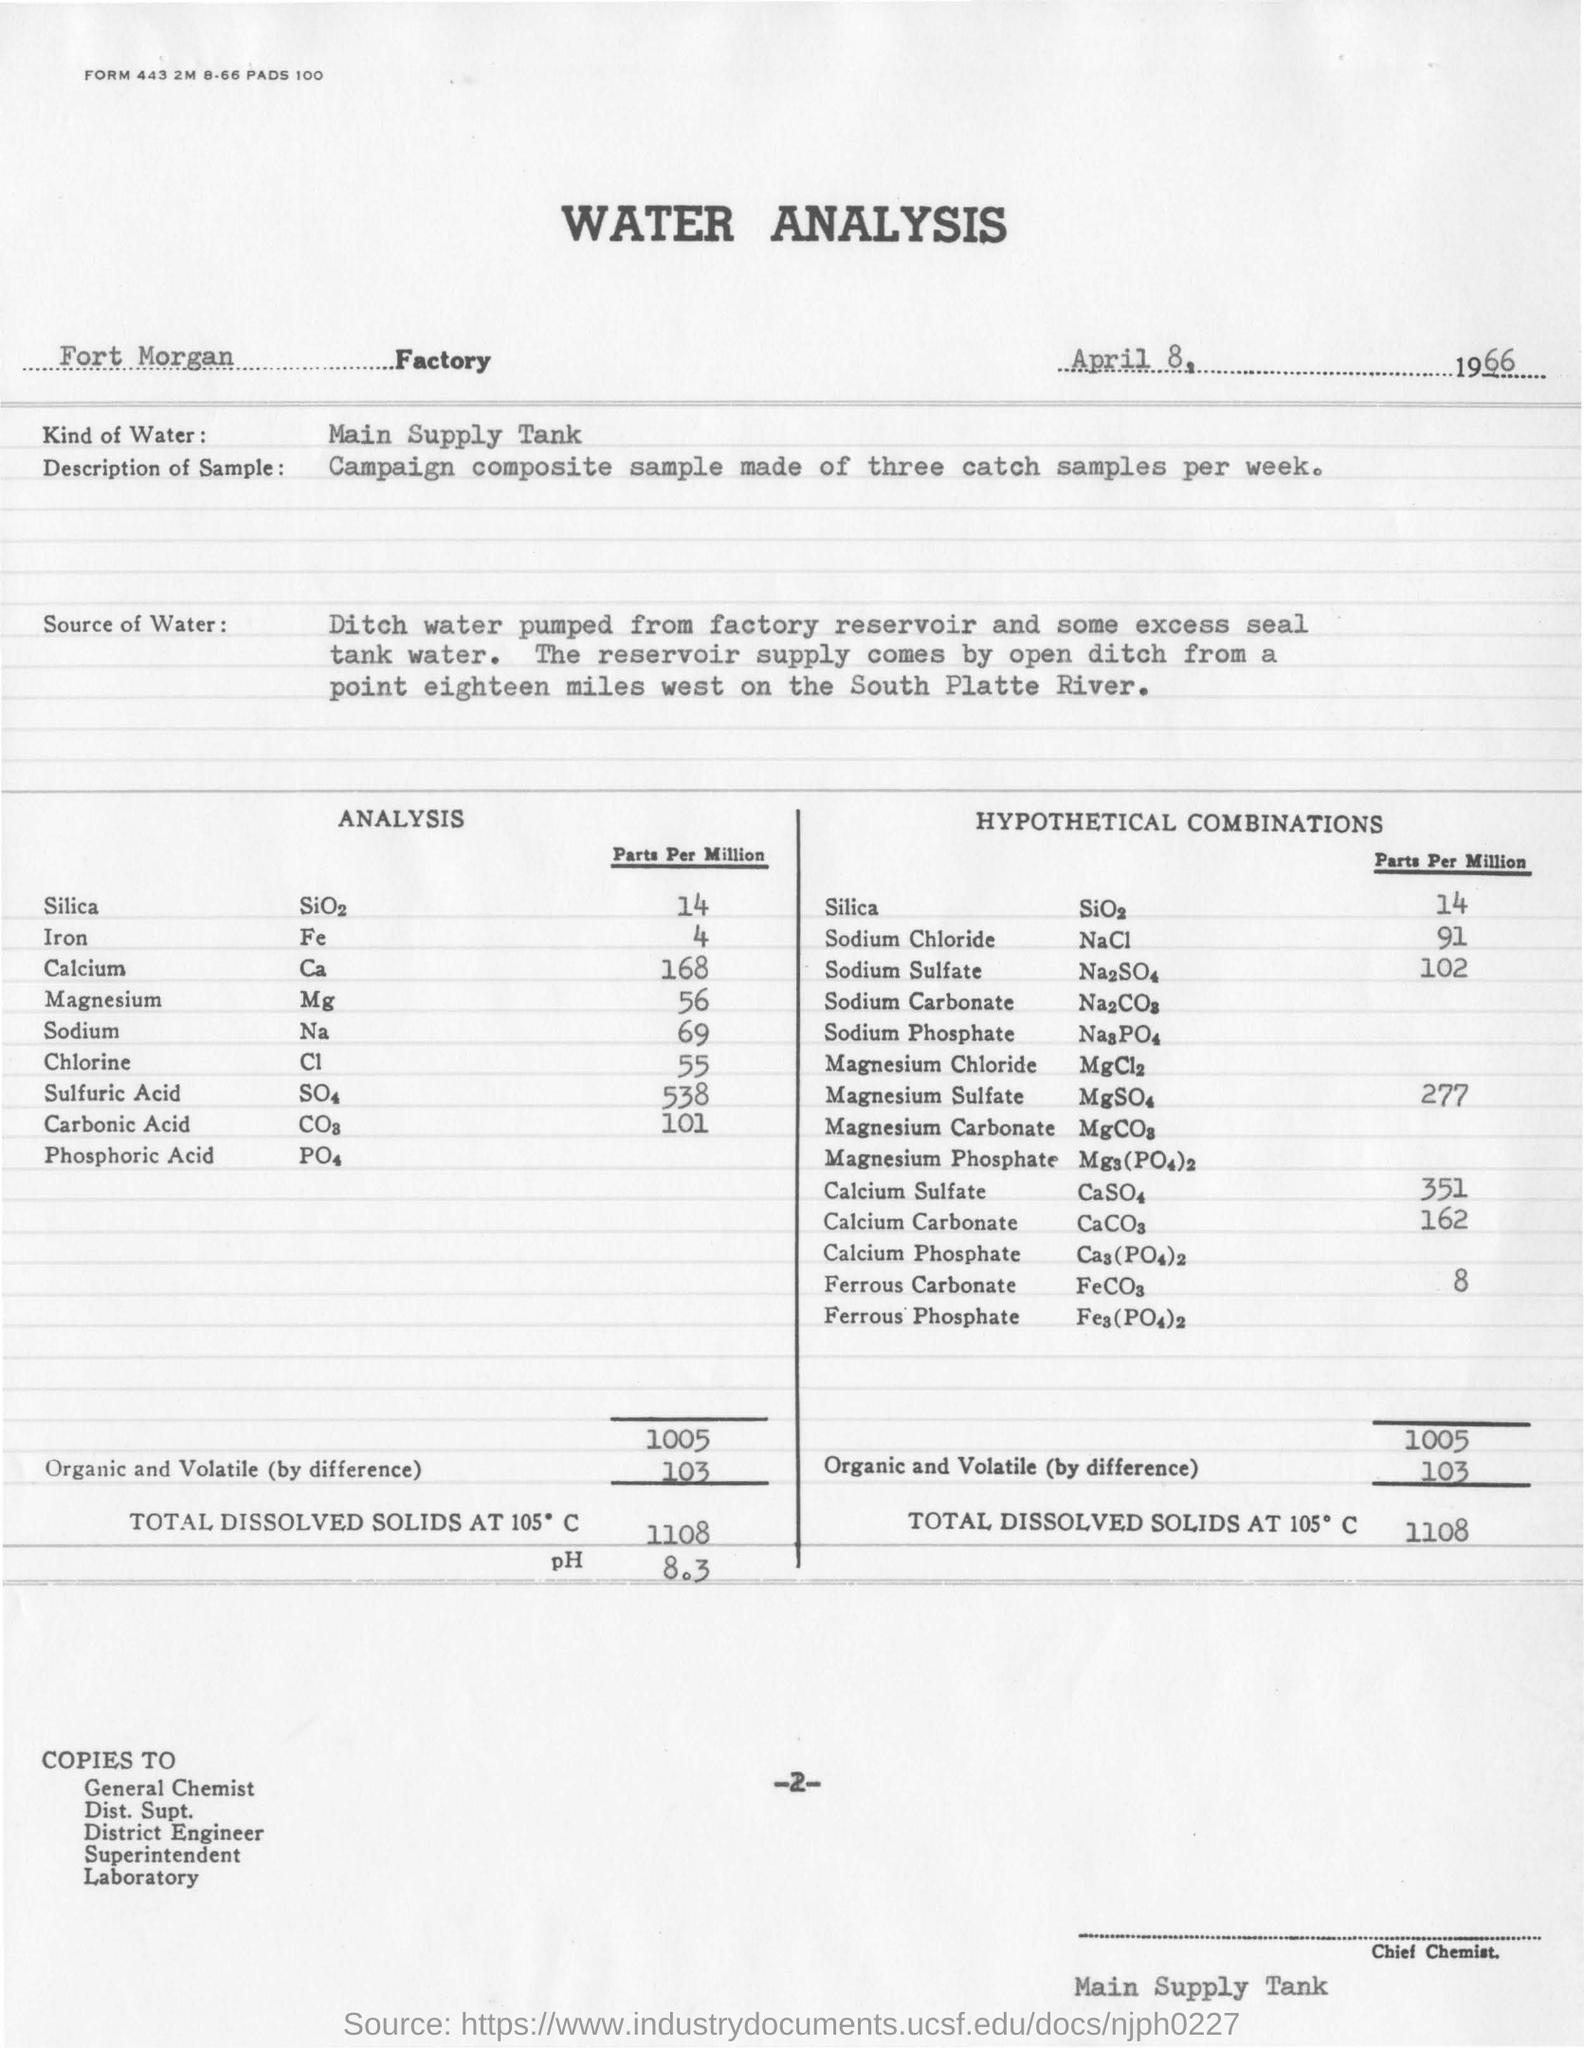Indicate a few pertinent items in this graphic. The document provides the date of April 8, 1966. The type of water used in the analysis is the main supply tank. According to the form, "Kind of water" refers to the main supply tank. 